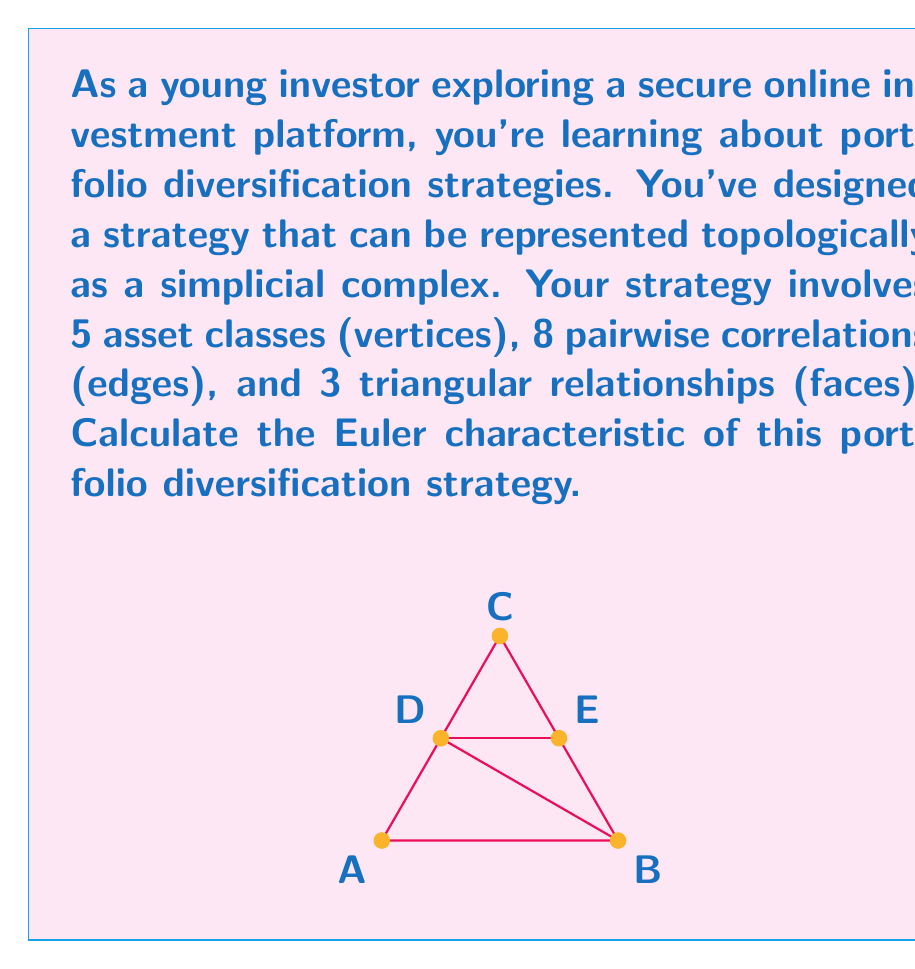Give your solution to this math problem. To calculate the Euler characteristic of this portfolio diversification strategy, we'll use the formula:

$$\chi = V - E + F$$

Where:
$\chi$ is the Euler characteristic
$V$ is the number of vertices (asset classes)
$E$ is the number of edges (pairwise correlations)
$F$ is the number of faces (triangular relationships)

Given:
- $V = 5$ (asset classes)
- $E = 8$ (pairwise correlations)
- $F = 3$ (triangular relationships)

Let's substitute these values into the formula:

$$\chi = 5 - 8 + 3$$

Calculating:

$$\chi = 0$$

The Euler characteristic of this portfolio diversification strategy is 0.

This result has interesting implications for the topology of your investment strategy. An Euler characteristic of 0 suggests that your strategy has a similar topological structure to a torus or a cylinder, indicating a balanced and interconnected approach to diversification.
Answer: $\chi = 0$ 